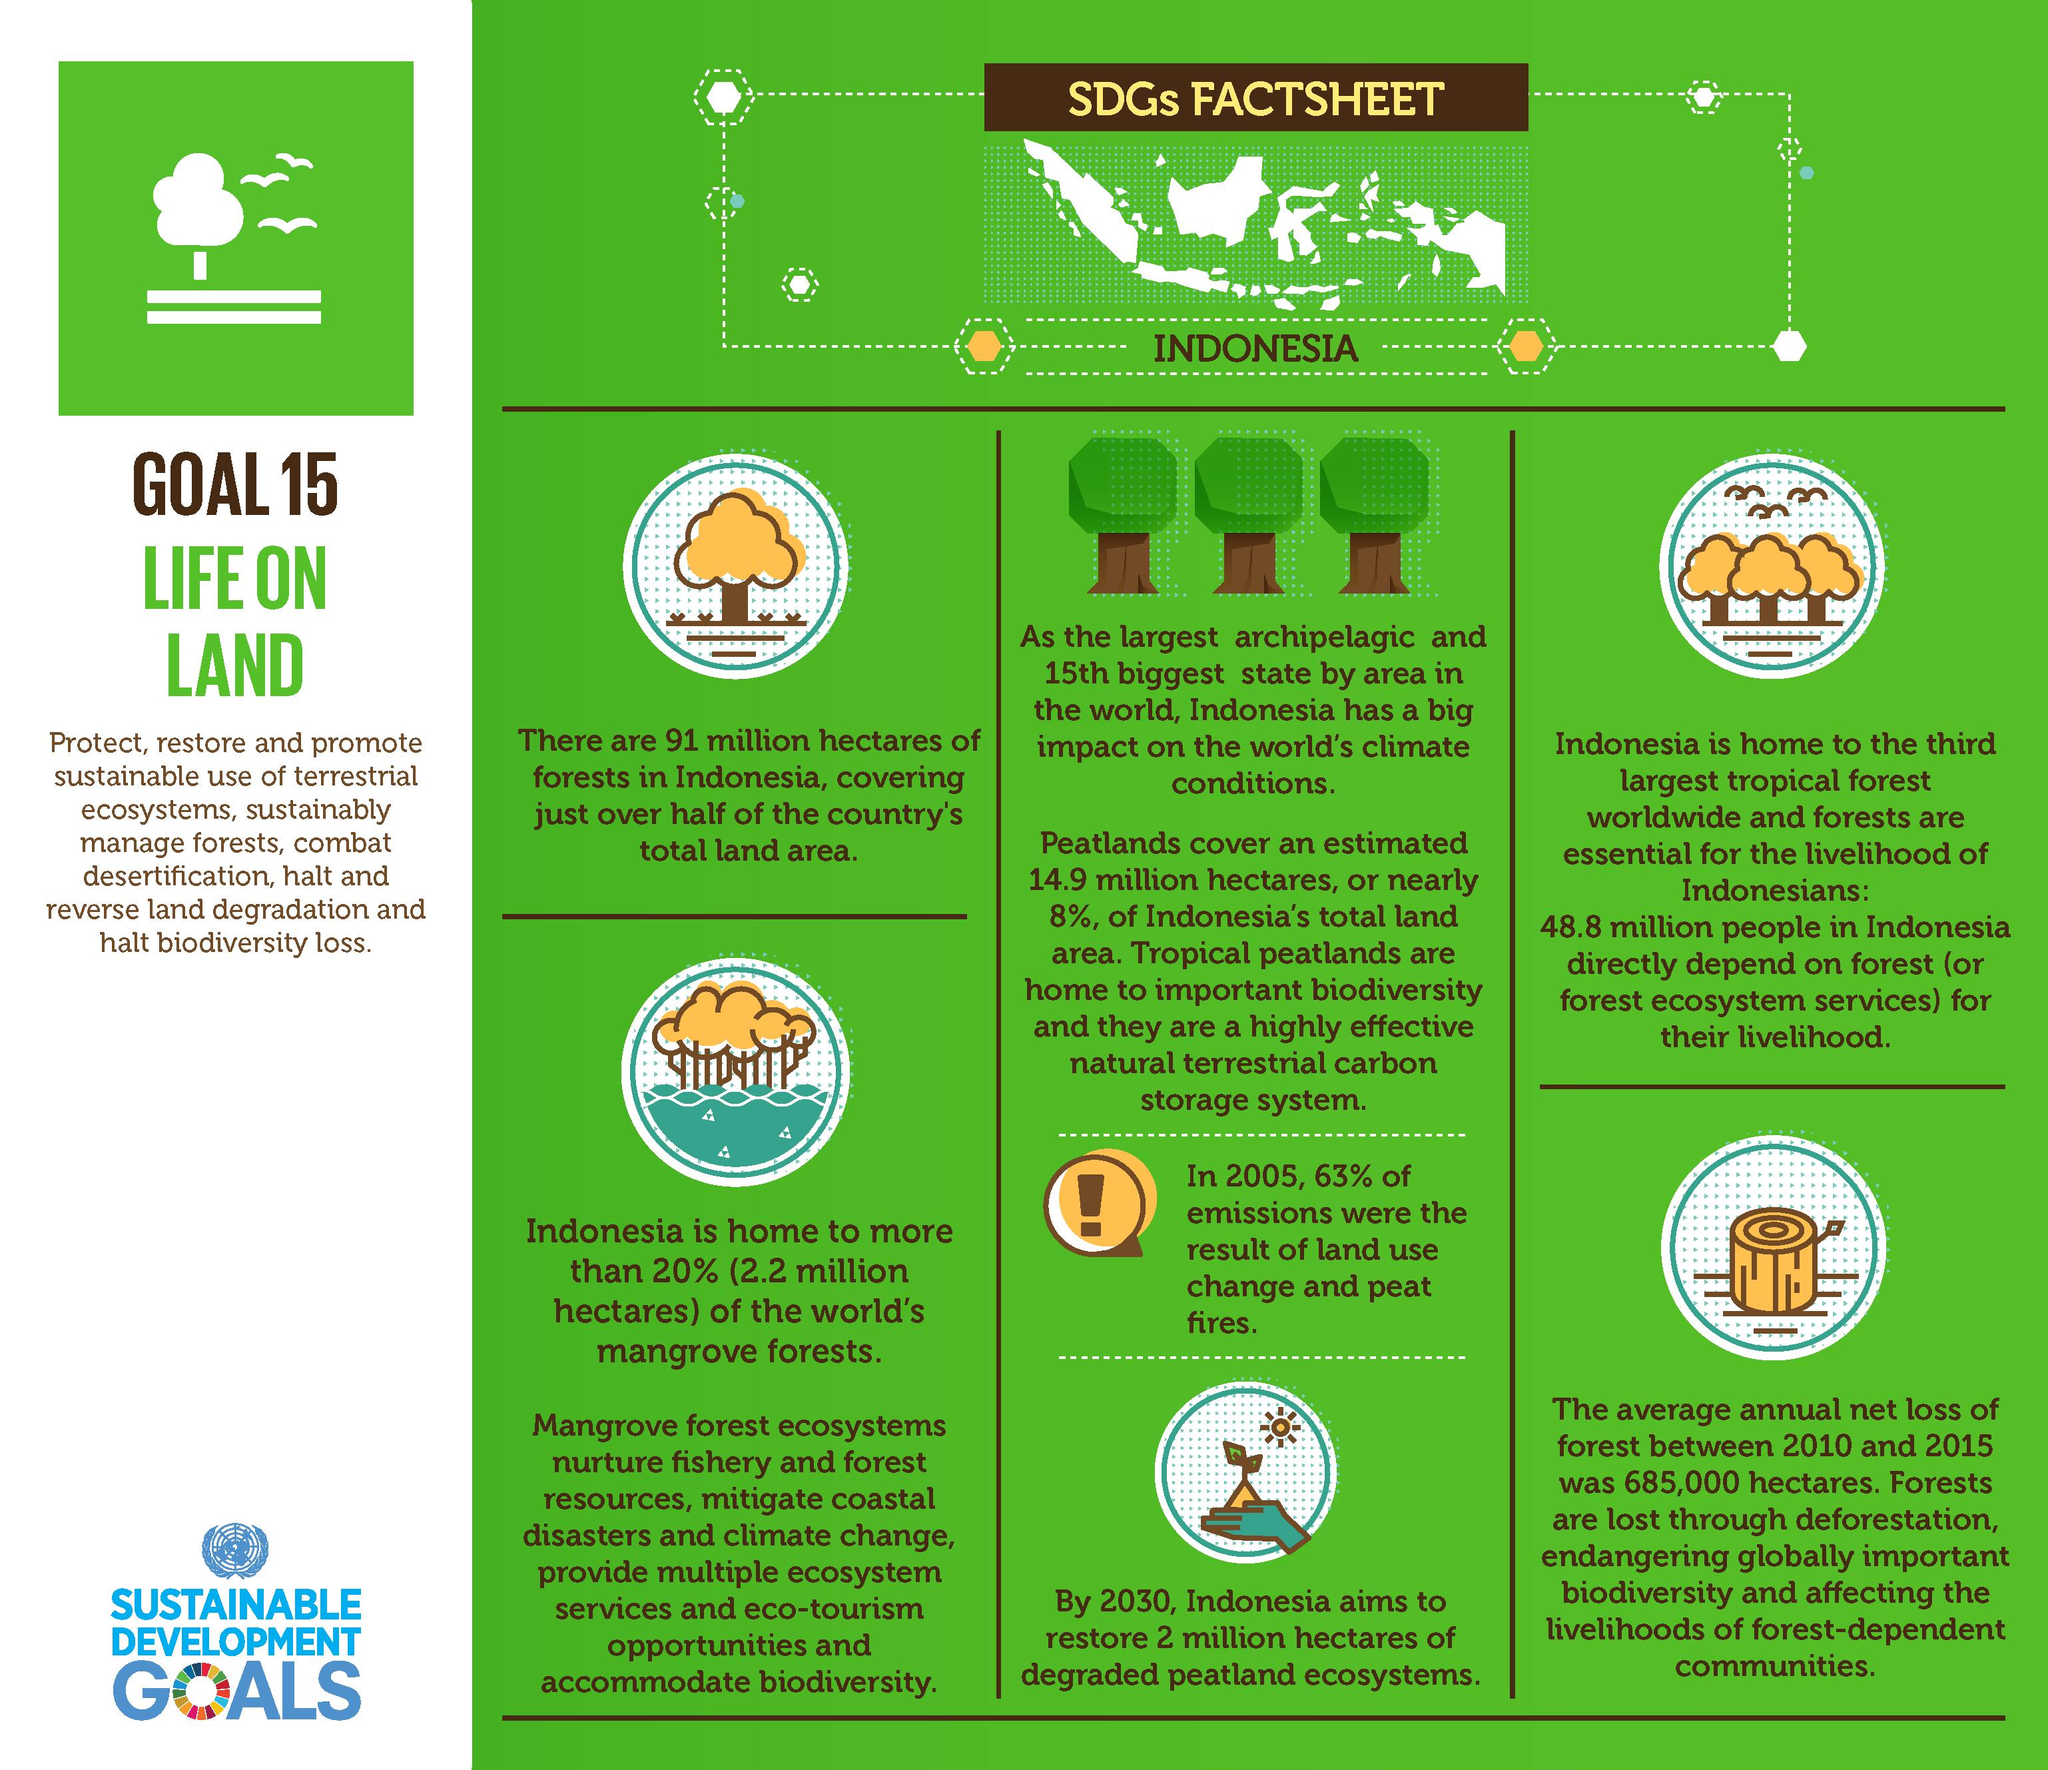Give some essential details in this illustration. The world's mangrove forests in Indonesia cover a total area of approximately 2.2 million hectares. Approximately 8% of Indonesia's total land area is covered by peatlands. By 2030, it is expected that approximately 2 million hectares of degraded peatland ecosystem in Indonesia will be restored. Indonesia's forest area is approximately 91 million hectares. According to data, approximately 48.8 million people in Indonesia rely on forests for their primary source of livelihood. 